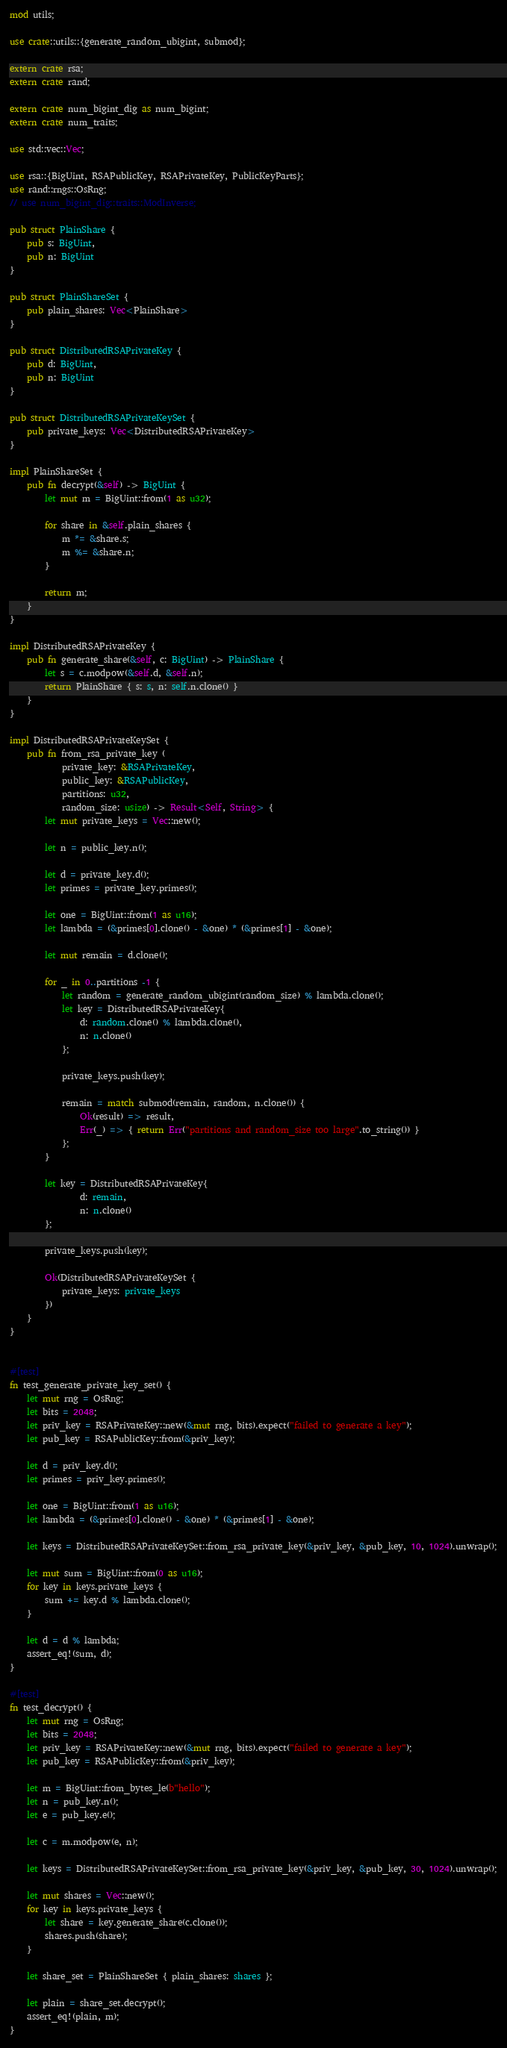<code> <loc_0><loc_0><loc_500><loc_500><_Rust_>mod utils;

use crate::utils::{generate_random_ubigint, submod};

extern crate rsa;
extern crate rand;

extern crate num_bigint_dig as num_bigint;
extern crate num_traits;

use std::vec::Vec;

use rsa::{BigUint, RSAPublicKey, RSAPrivateKey, PublicKeyParts};
use rand::rngs::OsRng;
// use num_bigint_dig::traits::ModInverse;

pub struct PlainShare {
    pub s: BigUint,
    pub n: BigUint
}

pub struct PlainShareSet {
    pub plain_shares: Vec<PlainShare>
}

pub struct DistributedRSAPrivateKey {
    pub d: BigUint,
    pub n: BigUint
}

pub struct DistributedRSAPrivateKeySet {
    pub private_keys: Vec<DistributedRSAPrivateKey>
}

impl PlainShareSet {
    pub fn decrypt(&self) -> BigUint {
        let mut m = BigUint::from(1 as u32);

        for share in &self.plain_shares {
            m *= &share.s;
            m %= &share.n;
        }
    
        return m;
    }
}

impl DistributedRSAPrivateKey {
    pub fn generate_share(&self, c: BigUint) -> PlainShare {
        let s = c.modpow(&self.d, &self.n);
        return PlainShare { s: s, n: self.n.clone() }
    }
}

impl DistributedRSAPrivateKeySet {
    pub fn from_rsa_private_key (
            private_key: &RSAPrivateKey,
            public_key: &RSAPublicKey,
            partitions: u32,
            random_size: usize) -> Result<Self, String> {
        let mut private_keys = Vec::new();

        let n = public_key.n();

        let d = private_key.d();        
        let primes = private_key.primes();

        let one = BigUint::from(1 as u16);
        let lambda = (&primes[0].clone() - &one) * (&primes[1] - &one);

        let mut remain = d.clone();

        for _ in 0..partitions -1 {
            let random = generate_random_ubigint(random_size) % lambda.clone();
            let key = DistributedRSAPrivateKey{ 
                d: random.clone() % lambda.clone(),
                n: n.clone()
            };
            
            private_keys.push(key);

            remain = match submod(remain, random, n.clone()) {
                Ok(result) => result,
                Err(_) => { return Err("partitions and random_size too large".to_string()) }
            };
        }

        let key = DistributedRSAPrivateKey{ 
                d: remain,
                n: n.clone()
        };

        private_keys.push(key);

        Ok(DistributedRSAPrivateKeySet {
            private_keys: private_keys
        })
    }
}


#[test]
fn test_generate_private_key_set() {
    let mut rng = OsRng;
    let bits = 2048;
    let priv_key = RSAPrivateKey::new(&mut rng, bits).expect("failed to generate a key");
    let pub_key = RSAPublicKey::from(&priv_key);

    let d = priv_key.d();
    let primes = priv_key.primes();

    let one = BigUint::from(1 as u16);
    let lambda = (&primes[0].clone() - &one) * (&primes[1] - &one);

    let keys = DistributedRSAPrivateKeySet::from_rsa_private_key(&priv_key, &pub_key, 10, 1024).unwrap();

    let mut sum = BigUint::from(0 as u16);
    for key in keys.private_keys {
        sum += key.d % lambda.clone();
    }

    let d = d % lambda;
    assert_eq!(sum, d);
}

#[test]
fn test_decrypt() {
    let mut rng = OsRng;
    let bits = 2048;
    let priv_key = RSAPrivateKey::new(&mut rng, bits).expect("failed to generate a key");
    let pub_key = RSAPublicKey::from(&priv_key);

    let m = BigUint::from_bytes_le(b"hello");
    let n = pub_key.n();
    let e = pub_key.e();

    let c = m.modpow(e, n);

    let keys = DistributedRSAPrivateKeySet::from_rsa_private_key(&priv_key, &pub_key, 30, 1024).unwrap();

    let mut shares = Vec::new();
    for key in keys.private_keys {
        let share = key.generate_share(c.clone());
        shares.push(share);
    }

    let share_set = PlainShareSet { plain_shares: shares };

    let plain = share_set.decrypt();
    assert_eq!(plain, m);
}</code> 